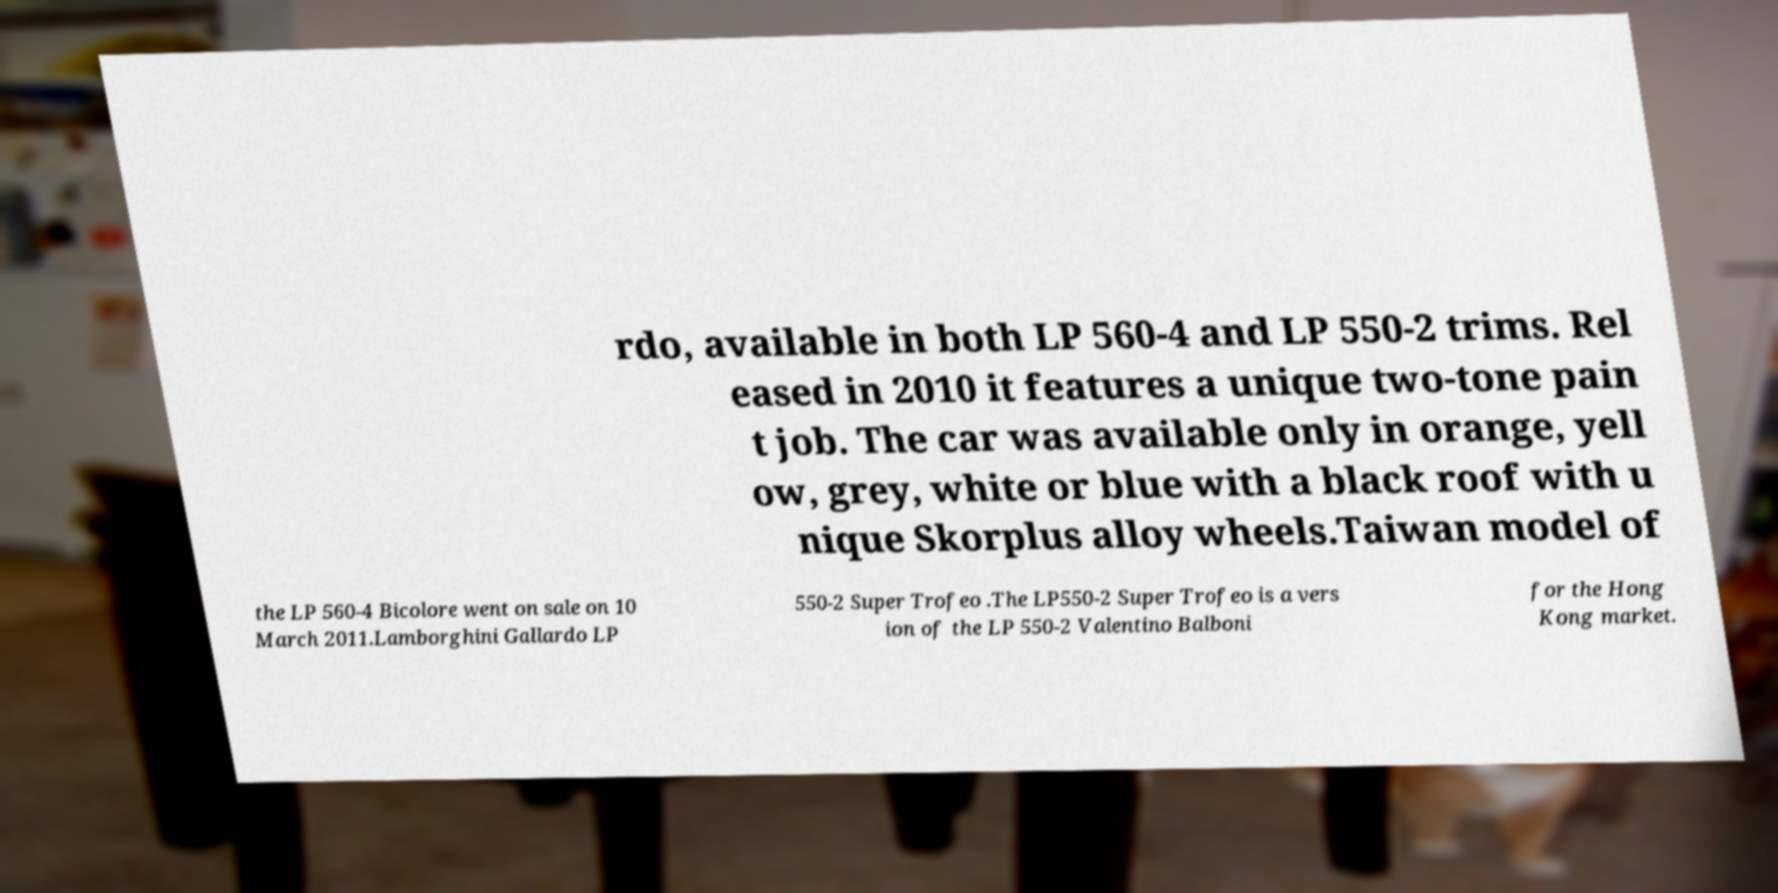There's text embedded in this image that I need extracted. Can you transcribe it verbatim? rdo, available in both LP 560-4 and LP 550-2 trims. Rel eased in 2010 it features a unique two-tone pain t job. The car was available only in orange, yell ow, grey, white or blue with a black roof with u nique Skorplus alloy wheels.Taiwan model of the LP 560-4 Bicolore went on sale on 10 March 2011.Lamborghini Gallardo LP 550-2 Super Trofeo .The LP550-2 Super Trofeo is a vers ion of the LP 550-2 Valentino Balboni for the Hong Kong market. 